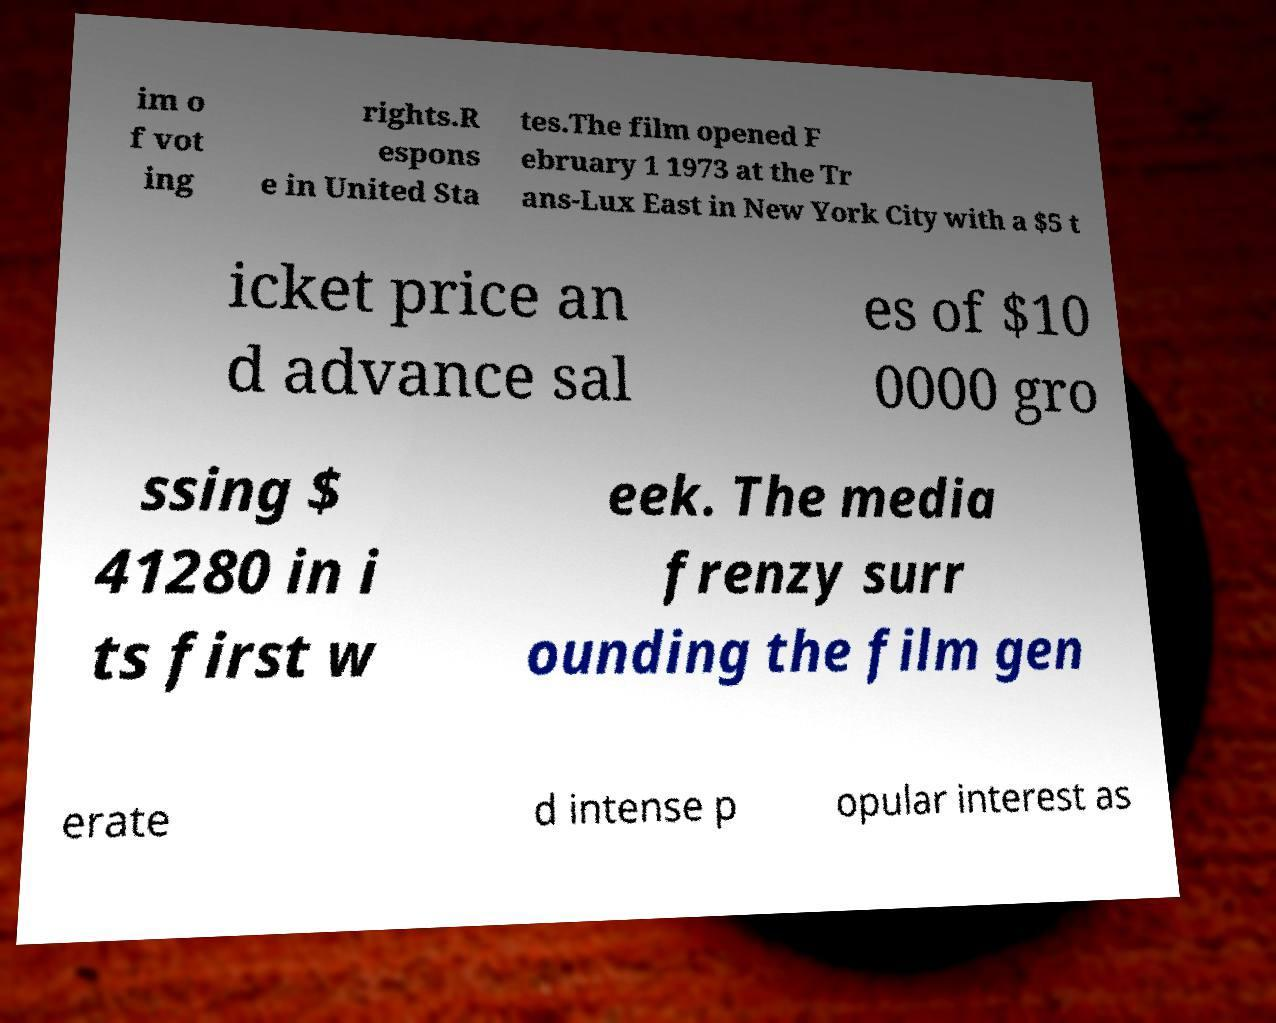There's text embedded in this image that I need extracted. Can you transcribe it verbatim? im o f vot ing rights.R espons e in United Sta tes.The film opened F ebruary 1 1973 at the Tr ans-Lux East in New York City with a $5 t icket price an d advance sal es of $10 0000 gro ssing $ 41280 in i ts first w eek. The media frenzy surr ounding the film gen erate d intense p opular interest as 